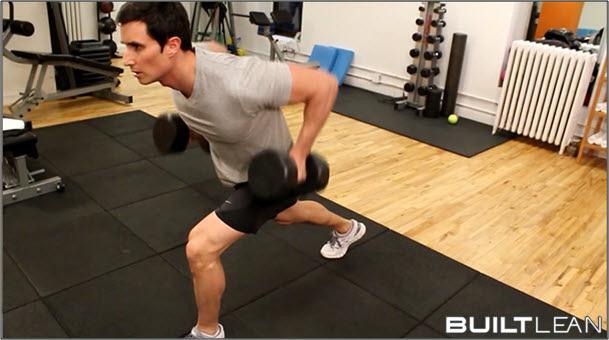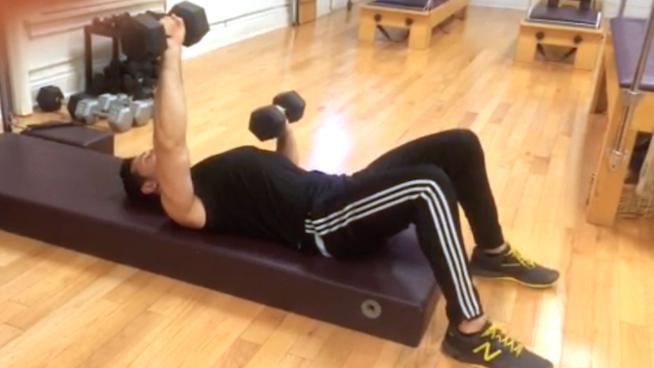The first image is the image on the left, the second image is the image on the right. For the images displayed, is the sentence "One of the guys does some leg-work near a red wall." factually correct? Answer yes or no. No. The first image is the image on the left, the second image is the image on the right. Evaluate the accuracy of this statement regarding the images: "There is a man wearing a black shirt and black shorts with a dumbbell in each hand.". Is it true? Answer yes or no. No. 